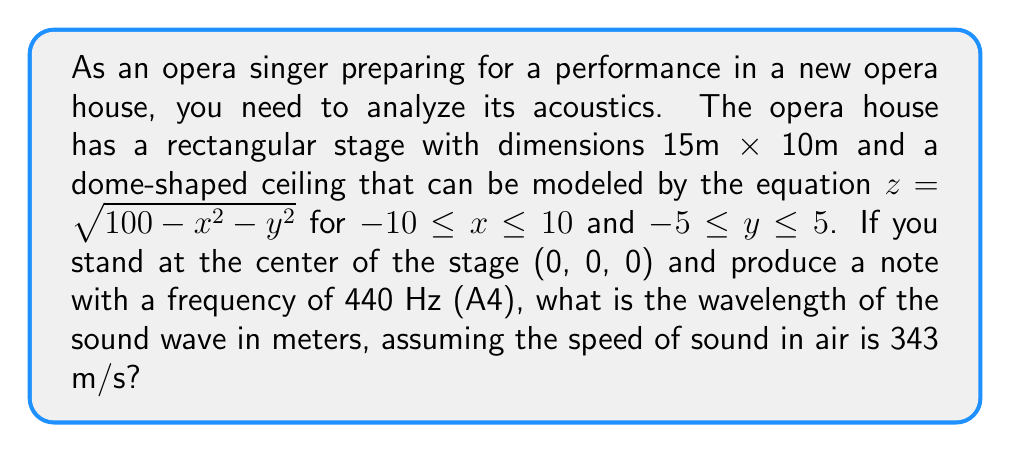Help me with this question. To solve this problem, we need to use the wave equation that relates the speed of sound, frequency, and wavelength. The equation is:

$$v = f \lambda$$

Where:
$v$ is the speed of sound in m/s
$f$ is the frequency in Hz
$\lambda$ is the wavelength in m

We are given:
$v = 343$ m/s (speed of sound in air)
$f = 440$ Hz (frequency of A4 note)

Let's substitute these values into the equation:

$$343 = 440 \lambda$$

Now, we can solve for $\lambda$:

$$\lambda = \frac{343}{440}$$

$$\lambda = 0.77954545...$$

Rounding to three decimal places, we get:

$$\lambda \approx 0.780 \text{ m}$$

This wavelength represents the distance between two consecutive compressions or rarefactions of the sound wave produced by the A4 note in the opera house.

It's worth noting that while the dimensions of the stage and the equation of the dome-shaped ceiling were provided, they weren't necessary for calculating the wavelength. However, these factors would be important for analyzing how the sound wave reflects and propagates within the opera house, which could affect the overall acoustics and sound quality experienced by the audience.
Answer: 0.780 m 